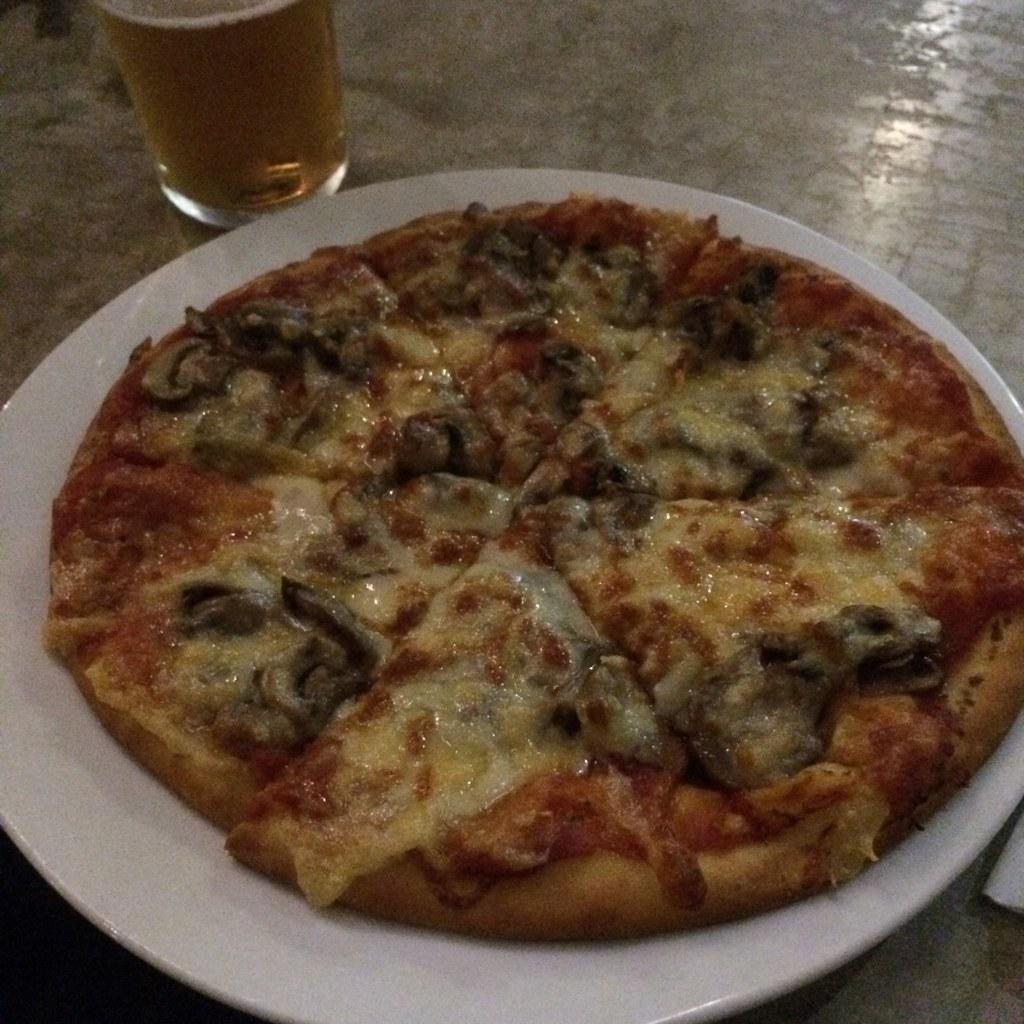Please provide a concise description of this image. On the platform there is a plate and glass. In the glass I can see liquid. On the plate there is a pizza.   